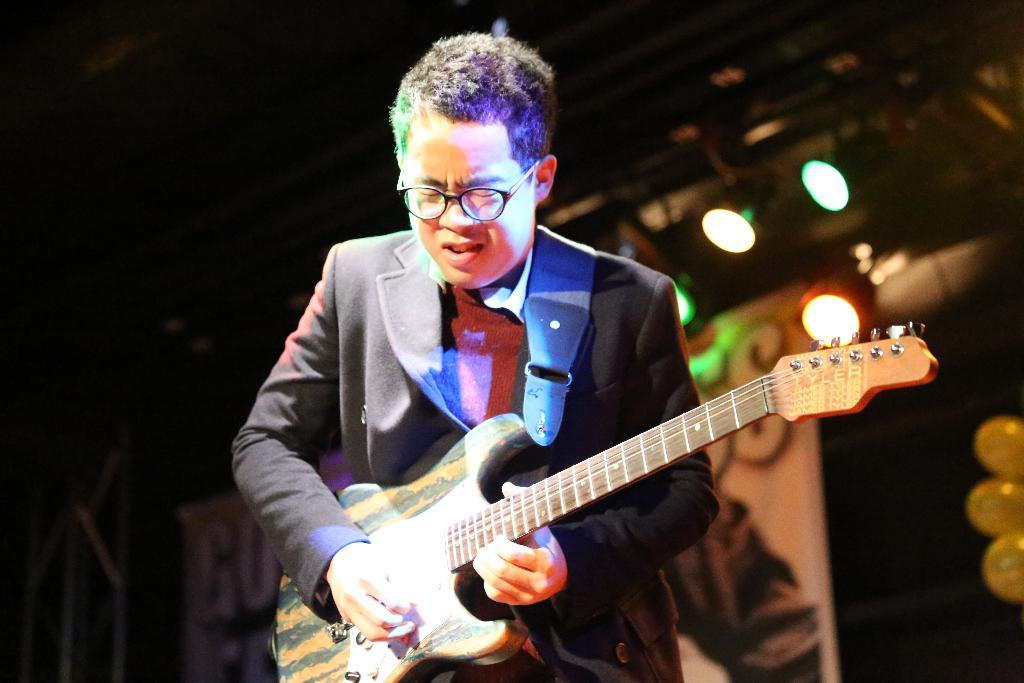What is the main subject of the image? The main subject of the image is a man. What is the man doing in the image? The man is standing in the image. What object is the man holding in the image? The man is holding a guitar in his hand. What type of building can be seen in the background of the image? There is no building visible in the image; it only features a man holding a guitar. What agreement is the man discussing with the guitar in the image? There is no discussion or agreement taking place in the image; the man is simply holding a guitar. 